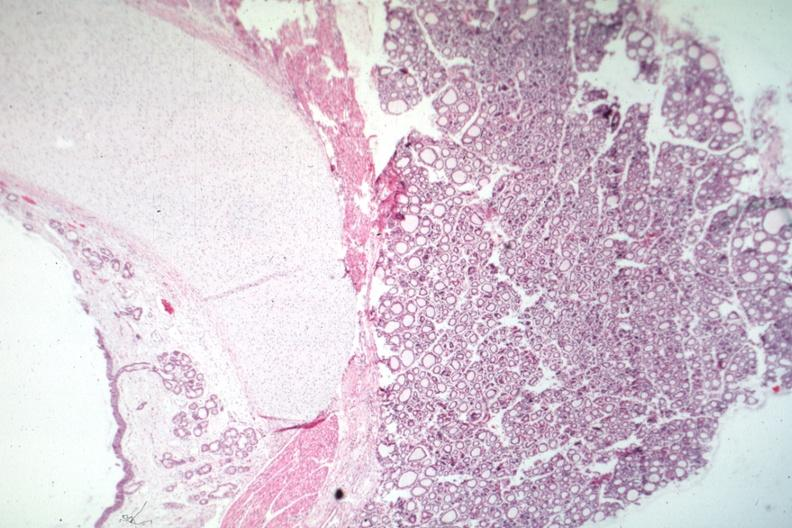s amyloidosis present?
Answer the question using a single word or phrase. No 